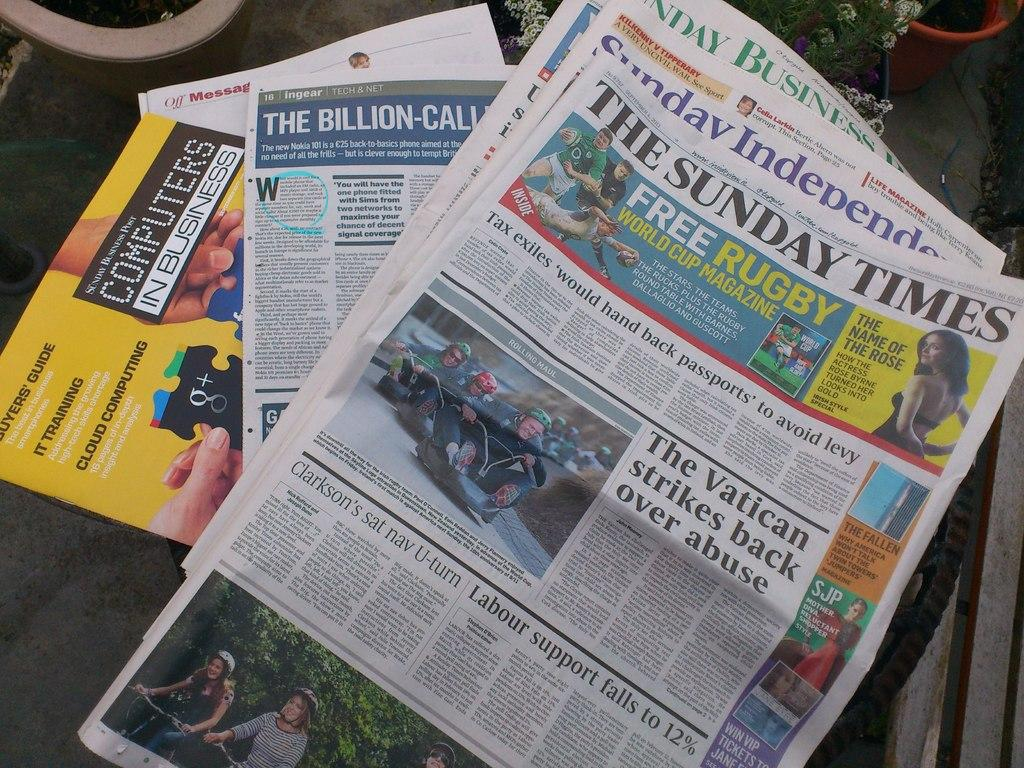<image>
Give a short and clear explanation of the subsequent image. The Vatican once again makes the top news headline. 